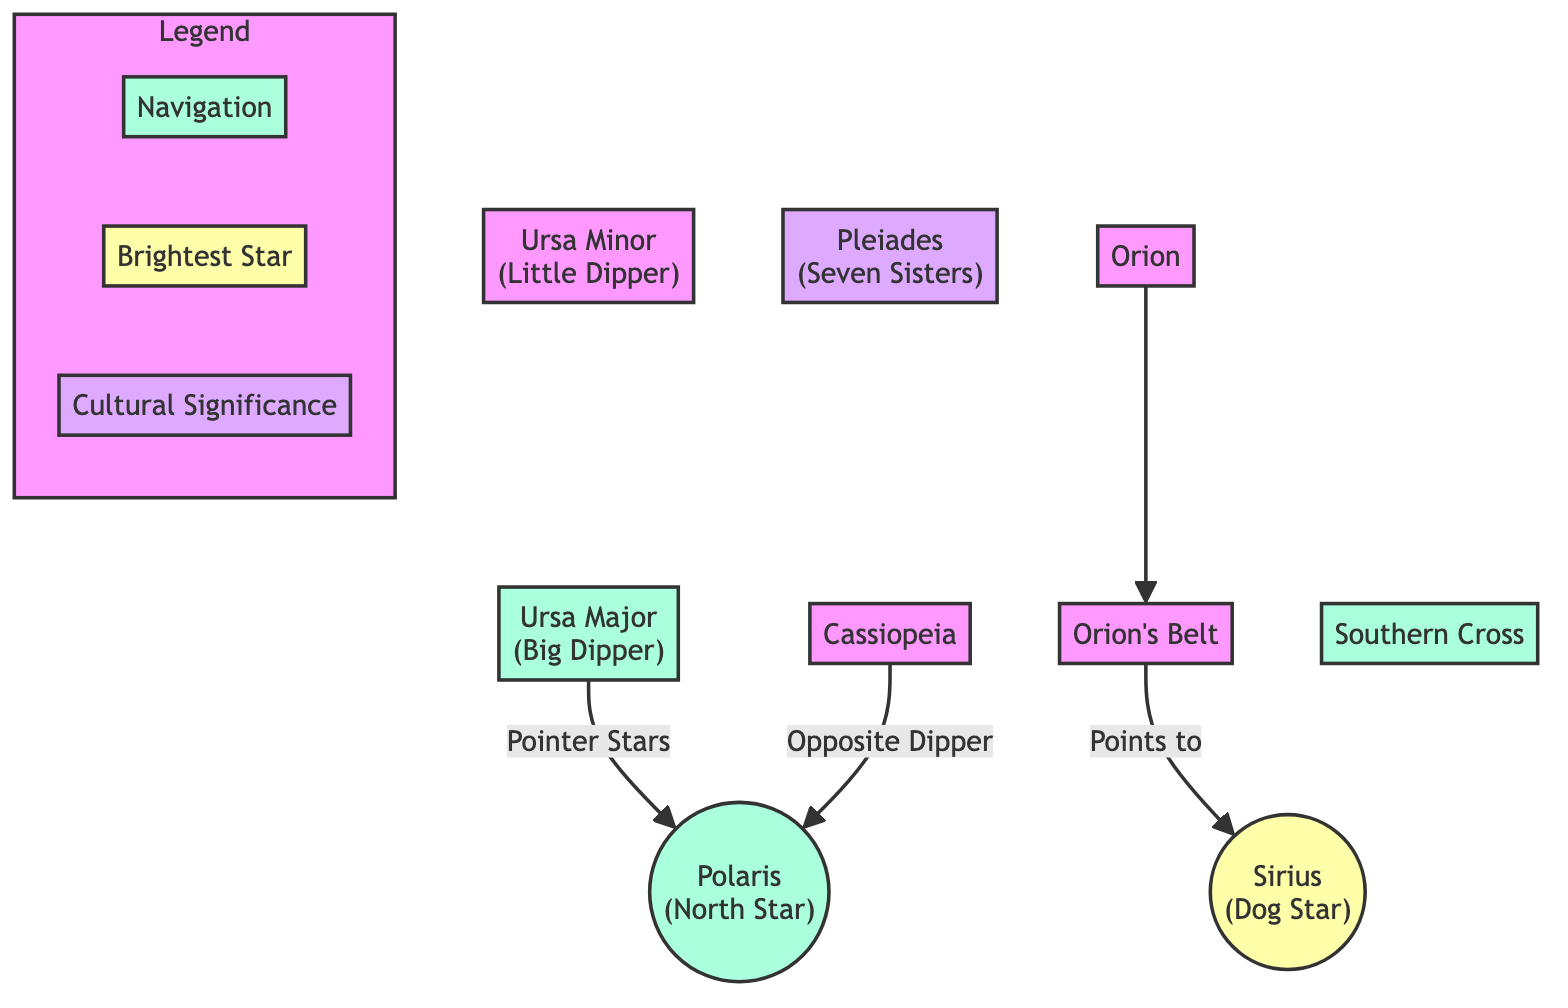What is the brightest star illustrated in the diagram? The diagram prominently displays Sirius as the brightest star, identified with the label "(Dog Star)" in the bright class section.
Answer: Sirius Which constellation points to Polaris? The constellation Ursa Major is noted for having pointer stars directing towards Polaris, as shown by the relationship arrow in the diagram.
Answer: Ursa Major How many constellations are labeled for their cultural significance? The diagram marks one constellation, Pleiades (Seven Sisters), specifically for its cultural significance, noted below the constellation label.
Answer: One What does Orion's Belt point to? According to the diagram, Orion's Belt points to Sirius, which is highlighted as the Dog Star directly related through an arrow.
Answer: Sirius Which constellation is opposite Polaris according to the diagram? Cassiopeia is indicated in the diagram to be opposite Polaris, as illustrated by the relationship mentioned in the connecting lines.
Answer: Cassiopeia In total, how many constellations are marked as navigation aids? The diagram shows three constellations labeled for navigation: Ursa Major, Polaris, and Southern Cross. Counting these provides the total.
Answer: Three What is the relationship between Orion and Orion's Belt? The diagram indicates a direct connection, demonstrating that Orion consists of the belt, as visually represented by the connecting arrow.
Answer: Orion's Belt Which star is used as a reference point for navigation? The North Star, Polaris, is highlighted as a key reference point for navigation in the diagram, denoted in the navigation class.
Answer: Polaris How many nodes are related to navigation in the diagram? There are four nodes related to navigation in total: Polaris, Ursa Major, Southern Cross, and the implied Orion through its belt, leading to the total node count for navigation-specific references.
Answer: Four 